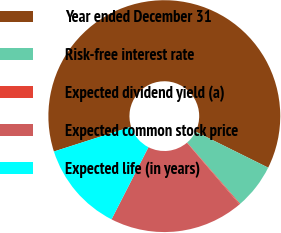Convert chart to OTSL. <chart><loc_0><loc_0><loc_500><loc_500><pie_chart><fcel>Year ended December 31<fcel>Risk-free interest rate<fcel>Expected dividend yield (a)<fcel>Expected common stock price<fcel>Expected life (in years)<nl><fcel>62.27%<fcel>6.33%<fcel>0.11%<fcel>18.76%<fcel>12.54%<nl></chart> 